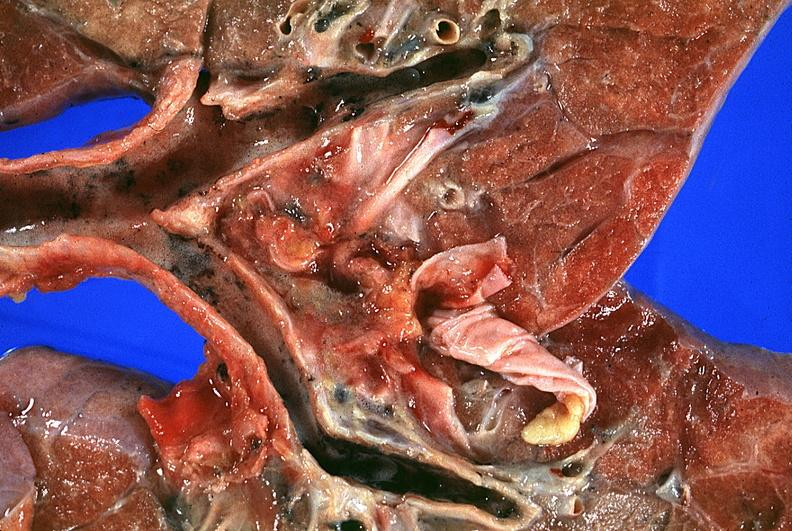what does this image show?
Answer the question using a single word or phrase. Lung 